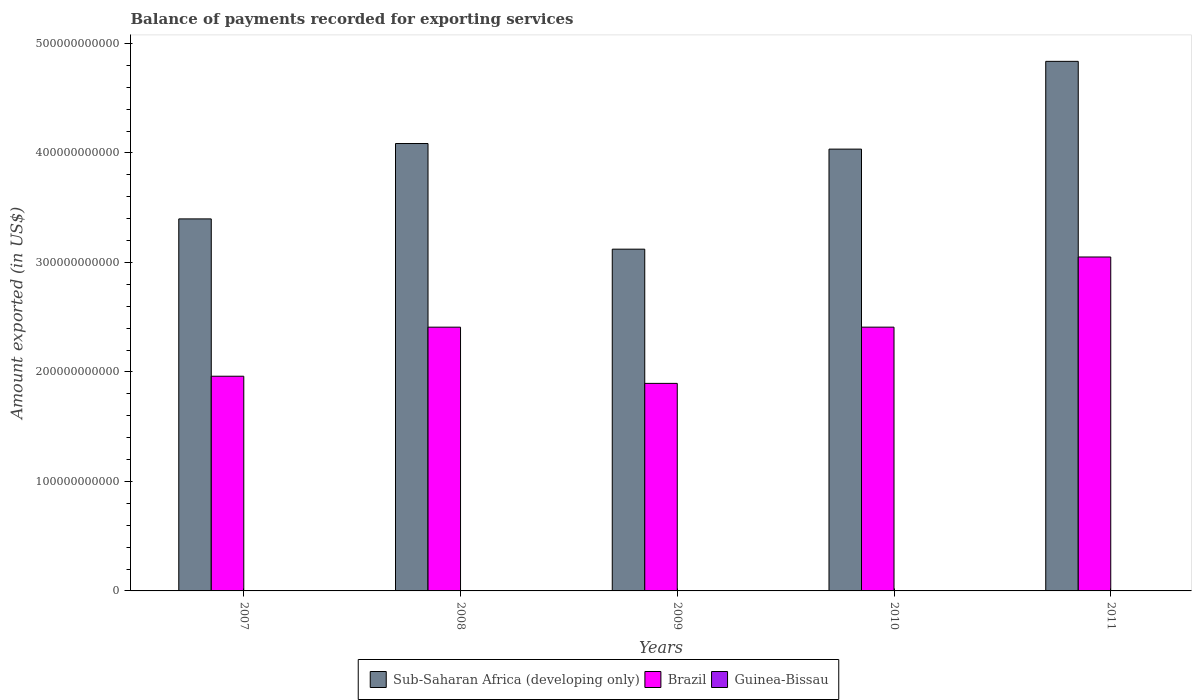Are the number of bars on each tick of the X-axis equal?
Provide a short and direct response. Yes. How many bars are there on the 2nd tick from the left?
Provide a short and direct response. 3. What is the amount exported in Sub-Saharan Africa (developing only) in 2011?
Give a very brief answer. 4.84e+11. Across all years, what is the maximum amount exported in Brazil?
Provide a succinct answer. 3.05e+11. Across all years, what is the minimum amount exported in Guinea-Bissau?
Make the answer very short. 1.41e+08. In which year was the amount exported in Sub-Saharan Africa (developing only) maximum?
Your answer should be very brief. 2011. What is the total amount exported in Sub-Saharan Africa (developing only) in the graph?
Ensure brevity in your answer.  1.95e+12. What is the difference between the amount exported in Sub-Saharan Africa (developing only) in 2007 and that in 2010?
Provide a short and direct response. -6.37e+1. What is the difference between the amount exported in Guinea-Bissau in 2011 and the amount exported in Sub-Saharan Africa (developing only) in 2009?
Give a very brief answer. -3.12e+11. What is the average amount exported in Sub-Saharan Africa (developing only) per year?
Offer a terse response. 3.90e+11. In the year 2008, what is the difference between the amount exported in Brazil and amount exported in Sub-Saharan Africa (developing only)?
Keep it short and to the point. -1.68e+11. In how many years, is the amount exported in Guinea-Bissau greater than 440000000000 US$?
Make the answer very short. 0. What is the ratio of the amount exported in Guinea-Bissau in 2008 to that in 2011?
Give a very brief answer. 0.58. Is the amount exported in Guinea-Bissau in 2007 less than that in 2009?
Your answer should be very brief. Yes. What is the difference between the highest and the second highest amount exported in Guinea-Bissau?
Keep it short and to the point. 1.14e+08. What is the difference between the highest and the lowest amount exported in Brazil?
Ensure brevity in your answer.  1.15e+11. In how many years, is the amount exported in Sub-Saharan Africa (developing only) greater than the average amount exported in Sub-Saharan Africa (developing only) taken over all years?
Make the answer very short. 3. Is the sum of the amount exported in Sub-Saharan Africa (developing only) in 2007 and 2009 greater than the maximum amount exported in Brazil across all years?
Make the answer very short. Yes. What does the 1st bar from the left in 2008 represents?
Provide a succinct answer. Sub-Saharan Africa (developing only). What does the 2nd bar from the right in 2007 represents?
Provide a succinct answer. Brazil. Is it the case that in every year, the sum of the amount exported in Guinea-Bissau and amount exported in Sub-Saharan Africa (developing only) is greater than the amount exported in Brazil?
Make the answer very short. Yes. How many bars are there?
Keep it short and to the point. 15. What is the difference between two consecutive major ticks on the Y-axis?
Offer a terse response. 1.00e+11. Does the graph contain any zero values?
Your answer should be compact. No. Does the graph contain grids?
Ensure brevity in your answer.  No. Where does the legend appear in the graph?
Ensure brevity in your answer.  Bottom center. How many legend labels are there?
Your response must be concise. 3. What is the title of the graph?
Your answer should be very brief. Balance of payments recorded for exporting services. Does "Turkmenistan" appear as one of the legend labels in the graph?
Keep it short and to the point. No. What is the label or title of the X-axis?
Ensure brevity in your answer.  Years. What is the label or title of the Y-axis?
Your answer should be very brief. Amount exported (in US$). What is the Amount exported (in US$) of Sub-Saharan Africa (developing only) in 2007?
Offer a very short reply. 3.40e+11. What is the Amount exported (in US$) of Brazil in 2007?
Provide a succinct answer. 1.96e+11. What is the Amount exported (in US$) in Guinea-Bissau in 2007?
Ensure brevity in your answer.  1.41e+08. What is the Amount exported (in US$) of Sub-Saharan Africa (developing only) in 2008?
Give a very brief answer. 4.09e+11. What is the Amount exported (in US$) of Brazil in 2008?
Provide a succinct answer. 2.41e+11. What is the Amount exported (in US$) in Guinea-Bissau in 2008?
Your response must be concise. 1.72e+08. What is the Amount exported (in US$) in Sub-Saharan Africa (developing only) in 2009?
Offer a terse response. 3.12e+11. What is the Amount exported (in US$) in Brazil in 2009?
Ensure brevity in your answer.  1.90e+11. What is the Amount exported (in US$) in Guinea-Bissau in 2009?
Make the answer very short. 1.63e+08. What is the Amount exported (in US$) in Sub-Saharan Africa (developing only) in 2010?
Your answer should be very brief. 4.04e+11. What is the Amount exported (in US$) of Brazil in 2010?
Ensure brevity in your answer.  2.41e+11. What is the Amount exported (in US$) of Guinea-Bissau in 2010?
Provide a succinct answer. 1.84e+08. What is the Amount exported (in US$) of Sub-Saharan Africa (developing only) in 2011?
Your answer should be compact. 4.84e+11. What is the Amount exported (in US$) in Brazil in 2011?
Provide a succinct answer. 3.05e+11. What is the Amount exported (in US$) in Guinea-Bissau in 2011?
Offer a terse response. 2.98e+08. Across all years, what is the maximum Amount exported (in US$) in Sub-Saharan Africa (developing only)?
Your response must be concise. 4.84e+11. Across all years, what is the maximum Amount exported (in US$) in Brazil?
Make the answer very short. 3.05e+11. Across all years, what is the maximum Amount exported (in US$) in Guinea-Bissau?
Ensure brevity in your answer.  2.98e+08. Across all years, what is the minimum Amount exported (in US$) in Sub-Saharan Africa (developing only)?
Offer a very short reply. 3.12e+11. Across all years, what is the minimum Amount exported (in US$) of Brazil?
Offer a very short reply. 1.90e+11. Across all years, what is the minimum Amount exported (in US$) of Guinea-Bissau?
Provide a short and direct response. 1.41e+08. What is the total Amount exported (in US$) of Sub-Saharan Africa (developing only) in the graph?
Provide a succinct answer. 1.95e+12. What is the total Amount exported (in US$) of Brazil in the graph?
Your answer should be very brief. 1.17e+12. What is the total Amount exported (in US$) of Guinea-Bissau in the graph?
Make the answer very short. 9.58e+08. What is the difference between the Amount exported (in US$) in Sub-Saharan Africa (developing only) in 2007 and that in 2008?
Offer a terse response. -6.88e+1. What is the difference between the Amount exported (in US$) of Brazil in 2007 and that in 2008?
Provide a succinct answer. -4.48e+1. What is the difference between the Amount exported (in US$) in Guinea-Bissau in 2007 and that in 2008?
Keep it short and to the point. -3.12e+07. What is the difference between the Amount exported (in US$) in Sub-Saharan Africa (developing only) in 2007 and that in 2009?
Your answer should be very brief. 2.76e+1. What is the difference between the Amount exported (in US$) in Brazil in 2007 and that in 2009?
Make the answer very short. 6.53e+09. What is the difference between the Amount exported (in US$) of Guinea-Bissau in 2007 and that in 2009?
Your answer should be very brief. -2.25e+07. What is the difference between the Amount exported (in US$) of Sub-Saharan Africa (developing only) in 2007 and that in 2010?
Give a very brief answer. -6.37e+1. What is the difference between the Amount exported (in US$) in Brazil in 2007 and that in 2010?
Make the answer very short. -4.48e+1. What is the difference between the Amount exported (in US$) in Guinea-Bissau in 2007 and that in 2010?
Provide a short and direct response. -4.29e+07. What is the difference between the Amount exported (in US$) of Sub-Saharan Africa (developing only) in 2007 and that in 2011?
Your response must be concise. -1.44e+11. What is the difference between the Amount exported (in US$) in Brazil in 2007 and that in 2011?
Your answer should be compact. -1.09e+11. What is the difference between the Amount exported (in US$) in Guinea-Bissau in 2007 and that in 2011?
Give a very brief answer. -1.57e+08. What is the difference between the Amount exported (in US$) in Sub-Saharan Africa (developing only) in 2008 and that in 2009?
Your answer should be very brief. 9.65e+1. What is the difference between the Amount exported (in US$) of Brazil in 2008 and that in 2009?
Provide a short and direct response. 5.13e+1. What is the difference between the Amount exported (in US$) of Guinea-Bissau in 2008 and that in 2009?
Make the answer very short. 8.68e+06. What is the difference between the Amount exported (in US$) of Sub-Saharan Africa (developing only) in 2008 and that in 2010?
Your response must be concise. 5.10e+09. What is the difference between the Amount exported (in US$) in Brazil in 2008 and that in 2010?
Ensure brevity in your answer.  -1.56e+07. What is the difference between the Amount exported (in US$) in Guinea-Bissau in 2008 and that in 2010?
Provide a succinct answer. -1.17e+07. What is the difference between the Amount exported (in US$) of Sub-Saharan Africa (developing only) in 2008 and that in 2011?
Give a very brief answer. -7.51e+1. What is the difference between the Amount exported (in US$) in Brazil in 2008 and that in 2011?
Your answer should be very brief. -6.41e+1. What is the difference between the Amount exported (in US$) in Guinea-Bissau in 2008 and that in 2011?
Give a very brief answer. -1.26e+08. What is the difference between the Amount exported (in US$) in Sub-Saharan Africa (developing only) in 2009 and that in 2010?
Your answer should be very brief. -9.14e+1. What is the difference between the Amount exported (in US$) in Brazil in 2009 and that in 2010?
Offer a terse response. -5.14e+1. What is the difference between the Amount exported (in US$) in Guinea-Bissau in 2009 and that in 2010?
Your answer should be compact. -2.04e+07. What is the difference between the Amount exported (in US$) in Sub-Saharan Africa (developing only) in 2009 and that in 2011?
Ensure brevity in your answer.  -1.72e+11. What is the difference between the Amount exported (in US$) in Brazil in 2009 and that in 2011?
Your answer should be very brief. -1.15e+11. What is the difference between the Amount exported (in US$) of Guinea-Bissau in 2009 and that in 2011?
Provide a short and direct response. -1.35e+08. What is the difference between the Amount exported (in US$) in Sub-Saharan Africa (developing only) in 2010 and that in 2011?
Make the answer very short. -8.02e+1. What is the difference between the Amount exported (in US$) of Brazil in 2010 and that in 2011?
Offer a terse response. -6.41e+1. What is the difference between the Amount exported (in US$) of Guinea-Bissau in 2010 and that in 2011?
Offer a very short reply. -1.14e+08. What is the difference between the Amount exported (in US$) of Sub-Saharan Africa (developing only) in 2007 and the Amount exported (in US$) of Brazil in 2008?
Your response must be concise. 9.89e+1. What is the difference between the Amount exported (in US$) in Sub-Saharan Africa (developing only) in 2007 and the Amount exported (in US$) in Guinea-Bissau in 2008?
Your response must be concise. 3.40e+11. What is the difference between the Amount exported (in US$) of Brazil in 2007 and the Amount exported (in US$) of Guinea-Bissau in 2008?
Give a very brief answer. 1.96e+11. What is the difference between the Amount exported (in US$) of Sub-Saharan Africa (developing only) in 2007 and the Amount exported (in US$) of Brazil in 2009?
Offer a very short reply. 1.50e+11. What is the difference between the Amount exported (in US$) of Sub-Saharan Africa (developing only) in 2007 and the Amount exported (in US$) of Guinea-Bissau in 2009?
Keep it short and to the point. 3.40e+11. What is the difference between the Amount exported (in US$) in Brazil in 2007 and the Amount exported (in US$) in Guinea-Bissau in 2009?
Keep it short and to the point. 1.96e+11. What is the difference between the Amount exported (in US$) in Sub-Saharan Africa (developing only) in 2007 and the Amount exported (in US$) in Brazil in 2010?
Your answer should be very brief. 9.89e+1. What is the difference between the Amount exported (in US$) of Sub-Saharan Africa (developing only) in 2007 and the Amount exported (in US$) of Guinea-Bissau in 2010?
Your answer should be compact. 3.40e+11. What is the difference between the Amount exported (in US$) of Brazil in 2007 and the Amount exported (in US$) of Guinea-Bissau in 2010?
Your answer should be compact. 1.96e+11. What is the difference between the Amount exported (in US$) of Sub-Saharan Africa (developing only) in 2007 and the Amount exported (in US$) of Brazil in 2011?
Give a very brief answer. 3.48e+1. What is the difference between the Amount exported (in US$) in Sub-Saharan Africa (developing only) in 2007 and the Amount exported (in US$) in Guinea-Bissau in 2011?
Keep it short and to the point. 3.39e+11. What is the difference between the Amount exported (in US$) of Brazil in 2007 and the Amount exported (in US$) of Guinea-Bissau in 2011?
Your answer should be compact. 1.96e+11. What is the difference between the Amount exported (in US$) of Sub-Saharan Africa (developing only) in 2008 and the Amount exported (in US$) of Brazil in 2009?
Offer a terse response. 2.19e+11. What is the difference between the Amount exported (in US$) in Sub-Saharan Africa (developing only) in 2008 and the Amount exported (in US$) in Guinea-Bissau in 2009?
Your response must be concise. 4.08e+11. What is the difference between the Amount exported (in US$) of Brazil in 2008 and the Amount exported (in US$) of Guinea-Bissau in 2009?
Ensure brevity in your answer.  2.41e+11. What is the difference between the Amount exported (in US$) in Sub-Saharan Africa (developing only) in 2008 and the Amount exported (in US$) in Brazil in 2010?
Your answer should be compact. 1.68e+11. What is the difference between the Amount exported (in US$) of Sub-Saharan Africa (developing only) in 2008 and the Amount exported (in US$) of Guinea-Bissau in 2010?
Your answer should be very brief. 4.08e+11. What is the difference between the Amount exported (in US$) in Brazil in 2008 and the Amount exported (in US$) in Guinea-Bissau in 2010?
Your response must be concise. 2.41e+11. What is the difference between the Amount exported (in US$) in Sub-Saharan Africa (developing only) in 2008 and the Amount exported (in US$) in Brazil in 2011?
Your answer should be compact. 1.04e+11. What is the difference between the Amount exported (in US$) in Sub-Saharan Africa (developing only) in 2008 and the Amount exported (in US$) in Guinea-Bissau in 2011?
Your answer should be very brief. 4.08e+11. What is the difference between the Amount exported (in US$) of Brazil in 2008 and the Amount exported (in US$) of Guinea-Bissau in 2011?
Make the answer very short. 2.41e+11. What is the difference between the Amount exported (in US$) of Sub-Saharan Africa (developing only) in 2009 and the Amount exported (in US$) of Brazil in 2010?
Make the answer very short. 7.12e+1. What is the difference between the Amount exported (in US$) of Sub-Saharan Africa (developing only) in 2009 and the Amount exported (in US$) of Guinea-Bissau in 2010?
Provide a short and direct response. 3.12e+11. What is the difference between the Amount exported (in US$) in Brazil in 2009 and the Amount exported (in US$) in Guinea-Bissau in 2010?
Offer a terse response. 1.89e+11. What is the difference between the Amount exported (in US$) in Sub-Saharan Africa (developing only) in 2009 and the Amount exported (in US$) in Brazil in 2011?
Your answer should be very brief. 7.14e+09. What is the difference between the Amount exported (in US$) in Sub-Saharan Africa (developing only) in 2009 and the Amount exported (in US$) in Guinea-Bissau in 2011?
Ensure brevity in your answer.  3.12e+11. What is the difference between the Amount exported (in US$) of Brazil in 2009 and the Amount exported (in US$) of Guinea-Bissau in 2011?
Provide a succinct answer. 1.89e+11. What is the difference between the Amount exported (in US$) of Sub-Saharan Africa (developing only) in 2010 and the Amount exported (in US$) of Brazil in 2011?
Ensure brevity in your answer.  9.85e+1. What is the difference between the Amount exported (in US$) in Sub-Saharan Africa (developing only) in 2010 and the Amount exported (in US$) in Guinea-Bissau in 2011?
Make the answer very short. 4.03e+11. What is the difference between the Amount exported (in US$) of Brazil in 2010 and the Amount exported (in US$) of Guinea-Bissau in 2011?
Make the answer very short. 2.41e+11. What is the average Amount exported (in US$) of Sub-Saharan Africa (developing only) per year?
Ensure brevity in your answer.  3.90e+11. What is the average Amount exported (in US$) in Brazil per year?
Make the answer very short. 2.34e+11. What is the average Amount exported (in US$) of Guinea-Bissau per year?
Provide a succinct answer. 1.92e+08. In the year 2007, what is the difference between the Amount exported (in US$) of Sub-Saharan Africa (developing only) and Amount exported (in US$) of Brazil?
Give a very brief answer. 1.44e+11. In the year 2007, what is the difference between the Amount exported (in US$) of Sub-Saharan Africa (developing only) and Amount exported (in US$) of Guinea-Bissau?
Your answer should be very brief. 3.40e+11. In the year 2007, what is the difference between the Amount exported (in US$) of Brazil and Amount exported (in US$) of Guinea-Bissau?
Keep it short and to the point. 1.96e+11. In the year 2008, what is the difference between the Amount exported (in US$) of Sub-Saharan Africa (developing only) and Amount exported (in US$) of Brazil?
Ensure brevity in your answer.  1.68e+11. In the year 2008, what is the difference between the Amount exported (in US$) in Sub-Saharan Africa (developing only) and Amount exported (in US$) in Guinea-Bissau?
Keep it short and to the point. 4.08e+11. In the year 2008, what is the difference between the Amount exported (in US$) in Brazil and Amount exported (in US$) in Guinea-Bissau?
Keep it short and to the point. 2.41e+11. In the year 2009, what is the difference between the Amount exported (in US$) of Sub-Saharan Africa (developing only) and Amount exported (in US$) of Brazil?
Your response must be concise. 1.23e+11. In the year 2009, what is the difference between the Amount exported (in US$) of Sub-Saharan Africa (developing only) and Amount exported (in US$) of Guinea-Bissau?
Offer a very short reply. 3.12e+11. In the year 2009, what is the difference between the Amount exported (in US$) of Brazil and Amount exported (in US$) of Guinea-Bissau?
Ensure brevity in your answer.  1.89e+11. In the year 2010, what is the difference between the Amount exported (in US$) in Sub-Saharan Africa (developing only) and Amount exported (in US$) in Brazil?
Provide a succinct answer. 1.63e+11. In the year 2010, what is the difference between the Amount exported (in US$) in Sub-Saharan Africa (developing only) and Amount exported (in US$) in Guinea-Bissau?
Your answer should be compact. 4.03e+11. In the year 2010, what is the difference between the Amount exported (in US$) in Brazil and Amount exported (in US$) in Guinea-Bissau?
Keep it short and to the point. 2.41e+11. In the year 2011, what is the difference between the Amount exported (in US$) in Sub-Saharan Africa (developing only) and Amount exported (in US$) in Brazil?
Your answer should be compact. 1.79e+11. In the year 2011, what is the difference between the Amount exported (in US$) of Sub-Saharan Africa (developing only) and Amount exported (in US$) of Guinea-Bissau?
Ensure brevity in your answer.  4.83e+11. In the year 2011, what is the difference between the Amount exported (in US$) of Brazil and Amount exported (in US$) of Guinea-Bissau?
Make the answer very short. 3.05e+11. What is the ratio of the Amount exported (in US$) in Sub-Saharan Africa (developing only) in 2007 to that in 2008?
Ensure brevity in your answer.  0.83. What is the ratio of the Amount exported (in US$) of Brazil in 2007 to that in 2008?
Your answer should be very brief. 0.81. What is the ratio of the Amount exported (in US$) in Guinea-Bissau in 2007 to that in 2008?
Your response must be concise. 0.82. What is the ratio of the Amount exported (in US$) in Sub-Saharan Africa (developing only) in 2007 to that in 2009?
Your response must be concise. 1.09. What is the ratio of the Amount exported (in US$) of Brazil in 2007 to that in 2009?
Make the answer very short. 1.03. What is the ratio of the Amount exported (in US$) of Guinea-Bissau in 2007 to that in 2009?
Offer a terse response. 0.86. What is the ratio of the Amount exported (in US$) of Sub-Saharan Africa (developing only) in 2007 to that in 2010?
Your answer should be very brief. 0.84. What is the ratio of the Amount exported (in US$) in Brazil in 2007 to that in 2010?
Ensure brevity in your answer.  0.81. What is the ratio of the Amount exported (in US$) of Guinea-Bissau in 2007 to that in 2010?
Your response must be concise. 0.77. What is the ratio of the Amount exported (in US$) in Sub-Saharan Africa (developing only) in 2007 to that in 2011?
Provide a short and direct response. 0.7. What is the ratio of the Amount exported (in US$) of Brazil in 2007 to that in 2011?
Ensure brevity in your answer.  0.64. What is the ratio of the Amount exported (in US$) in Guinea-Bissau in 2007 to that in 2011?
Ensure brevity in your answer.  0.47. What is the ratio of the Amount exported (in US$) in Sub-Saharan Africa (developing only) in 2008 to that in 2009?
Provide a succinct answer. 1.31. What is the ratio of the Amount exported (in US$) of Brazil in 2008 to that in 2009?
Your answer should be very brief. 1.27. What is the ratio of the Amount exported (in US$) of Guinea-Bissau in 2008 to that in 2009?
Keep it short and to the point. 1.05. What is the ratio of the Amount exported (in US$) in Sub-Saharan Africa (developing only) in 2008 to that in 2010?
Give a very brief answer. 1.01. What is the ratio of the Amount exported (in US$) of Guinea-Bissau in 2008 to that in 2010?
Your answer should be compact. 0.94. What is the ratio of the Amount exported (in US$) of Sub-Saharan Africa (developing only) in 2008 to that in 2011?
Your answer should be very brief. 0.84. What is the ratio of the Amount exported (in US$) in Brazil in 2008 to that in 2011?
Make the answer very short. 0.79. What is the ratio of the Amount exported (in US$) in Guinea-Bissau in 2008 to that in 2011?
Your answer should be very brief. 0.58. What is the ratio of the Amount exported (in US$) of Sub-Saharan Africa (developing only) in 2009 to that in 2010?
Ensure brevity in your answer.  0.77. What is the ratio of the Amount exported (in US$) in Brazil in 2009 to that in 2010?
Make the answer very short. 0.79. What is the ratio of the Amount exported (in US$) in Guinea-Bissau in 2009 to that in 2010?
Give a very brief answer. 0.89. What is the ratio of the Amount exported (in US$) in Sub-Saharan Africa (developing only) in 2009 to that in 2011?
Your response must be concise. 0.65. What is the ratio of the Amount exported (in US$) of Brazil in 2009 to that in 2011?
Offer a terse response. 0.62. What is the ratio of the Amount exported (in US$) of Guinea-Bissau in 2009 to that in 2011?
Provide a short and direct response. 0.55. What is the ratio of the Amount exported (in US$) in Sub-Saharan Africa (developing only) in 2010 to that in 2011?
Provide a short and direct response. 0.83. What is the ratio of the Amount exported (in US$) of Brazil in 2010 to that in 2011?
Your response must be concise. 0.79. What is the ratio of the Amount exported (in US$) in Guinea-Bissau in 2010 to that in 2011?
Offer a terse response. 0.62. What is the difference between the highest and the second highest Amount exported (in US$) of Sub-Saharan Africa (developing only)?
Your answer should be very brief. 7.51e+1. What is the difference between the highest and the second highest Amount exported (in US$) in Brazil?
Make the answer very short. 6.41e+1. What is the difference between the highest and the second highest Amount exported (in US$) of Guinea-Bissau?
Provide a succinct answer. 1.14e+08. What is the difference between the highest and the lowest Amount exported (in US$) in Sub-Saharan Africa (developing only)?
Give a very brief answer. 1.72e+11. What is the difference between the highest and the lowest Amount exported (in US$) in Brazil?
Offer a terse response. 1.15e+11. What is the difference between the highest and the lowest Amount exported (in US$) of Guinea-Bissau?
Provide a short and direct response. 1.57e+08. 